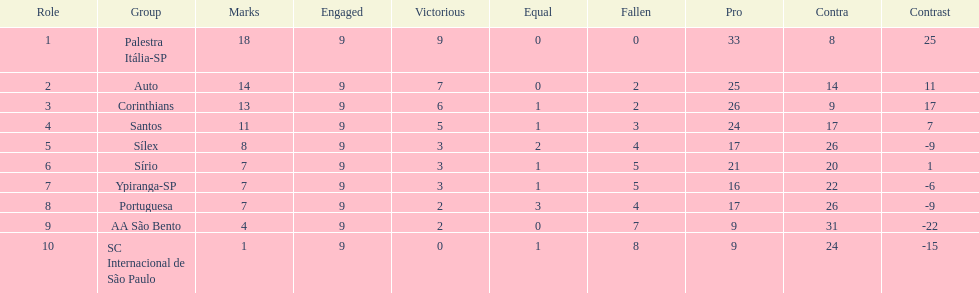Which is the only team to score 13 points in 9 games? Corinthians. 